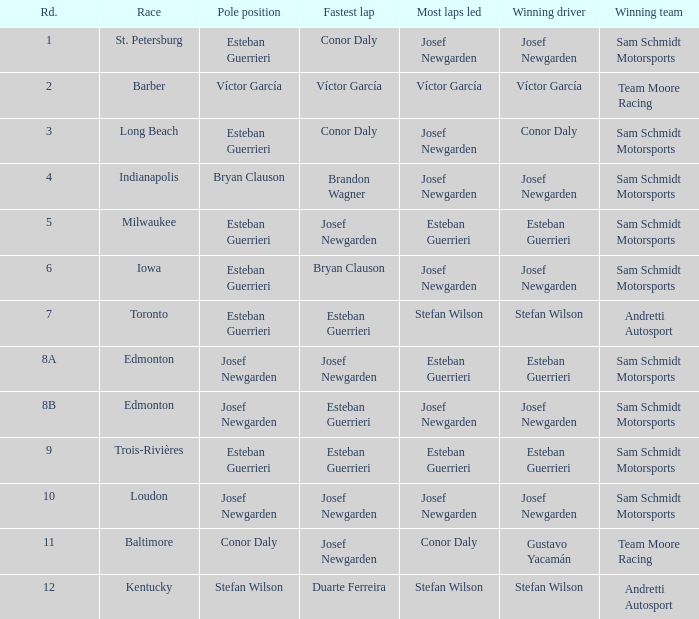Who led the most laps when brandon wagner had the fastest lap? Josef Newgarden. 